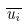<formula> <loc_0><loc_0><loc_500><loc_500>\overline { u _ { i } }</formula> 